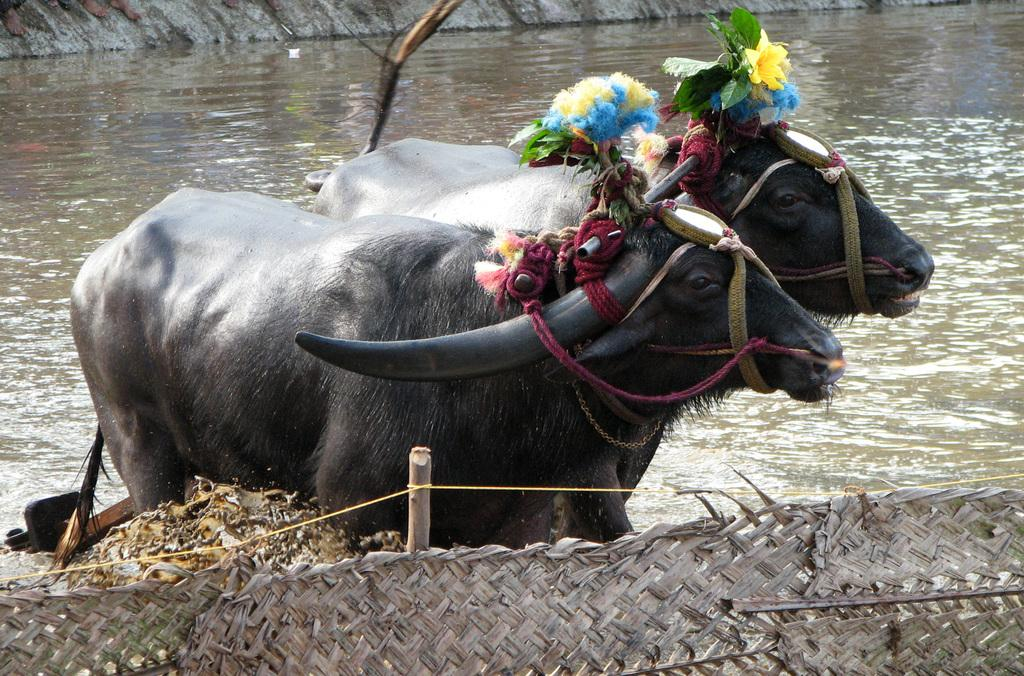What type of barrier can be seen in the image? There is a fence in the image. What animals are in the water behind the fence? Two buffaloes are in the water behind the fence. Can you describe anything in the background of the image? There are legs of a person visible in the background of the image. What type of meat is being prepared by the person in the image? There is no indication of meat or any food preparation in the image. 